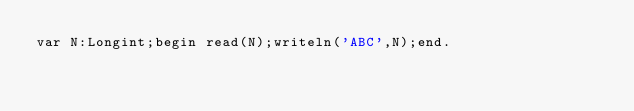Convert code to text. <code><loc_0><loc_0><loc_500><loc_500><_Pascal_>var N:Longint;begin read(N);writeln('ABC',N);end.</code> 